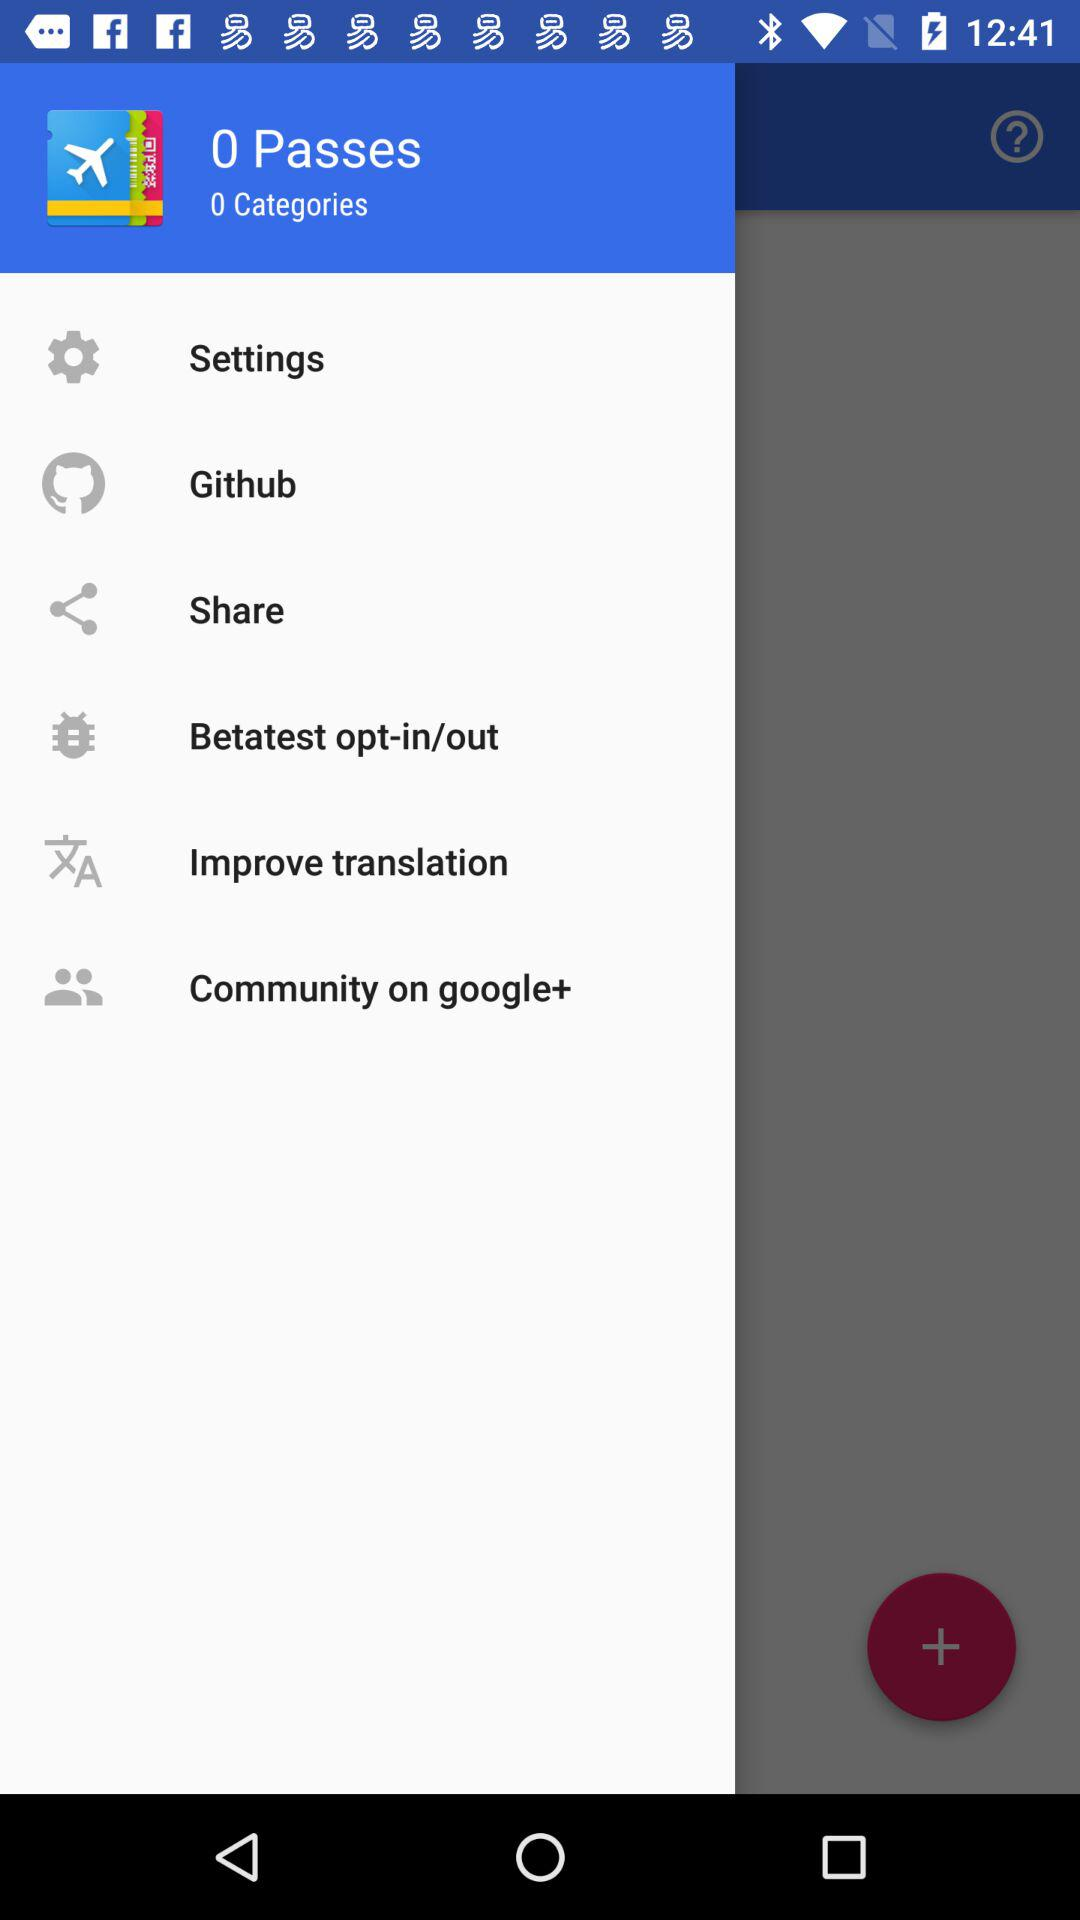What is the application name? The application name is "PassAndroid Passbook viewer". 